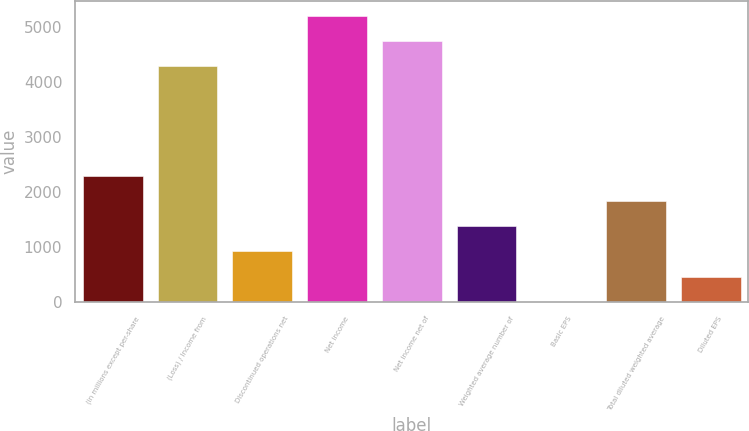<chart> <loc_0><loc_0><loc_500><loc_500><bar_chart><fcel>(in millions except per-share<fcel>(Loss) / Income from<fcel>Discontinued operations net<fcel>Net income<fcel>Net income net of<fcel>Weighted average number of<fcel>Basic EPS<fcel>Total diluted weighted average<fcel>Diluted EPS<nl><fcel>2301.82<fcel>4288.23<fcel>924.13<fcel>5206.69<fcel>4747.46<fcel>1383.36<fcel>5.67<fcel>1842.59<fcel>464.9<nl></chart> 